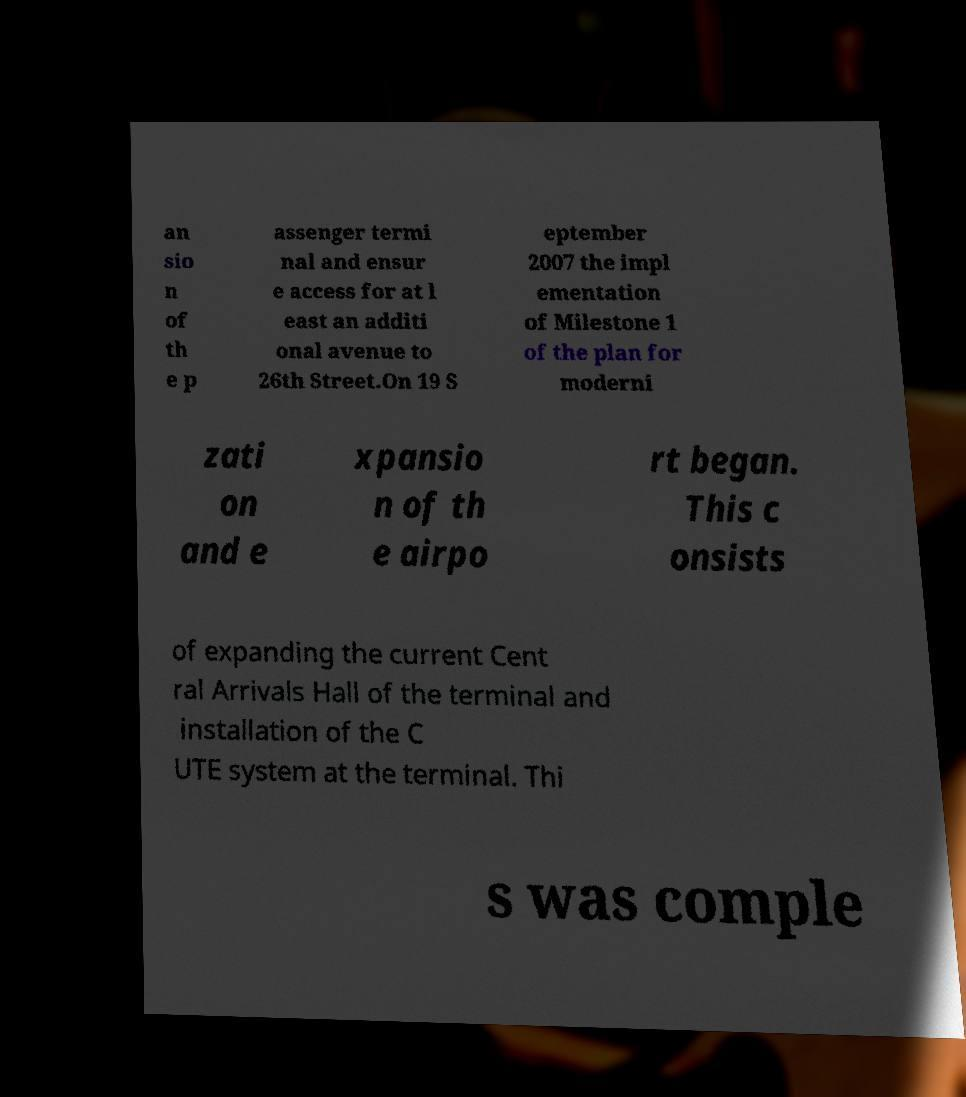For documentation purposes, I need the text within this image transcribed. Could you provide that? an sio n of th e p assenger termi nal and ensur e access for at l east an additi onal avenue to 26th Street.On 19 S eptember 2007 the impl ementation of Milestone 1 of the plan for moderni zati on and e xpansio n of th e airpo rt began. This c onsists of expanding the current Cent ral Arrivals Hall of the terminal and installation of the C UTE system at the terminal. Thi s was comple 